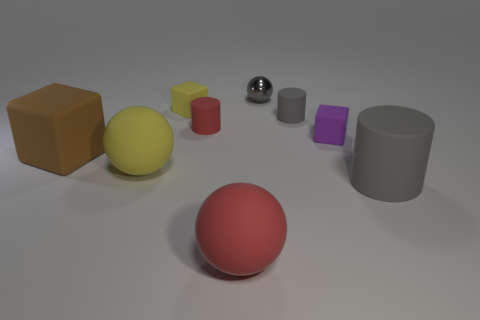Add 1 small yellow cylinders. How many objects exist? 10 Subtract all red cylinders. How many cylinders are left? 2 Subtract all purple spheres. How many gray cylinders are left? 2 Subtract all red cylinders. How many cylinders are left? 2 Subtract 2 cylinders. How many cylinders are left? 1 Subtract all spheres. How many objects are left? 6 Subtract all purple cubes. Subtract all cyan cylinders. How many cubes are left? 2 Subtract all tiny blue things. Subtract all large gray cylinders. How many objects are left? 8 Add 4 rubber blocks. How many rubber blocks are left? 7 Add 8 big gray rubber cylinders. How many big gray rubber cylinders exist? 9 